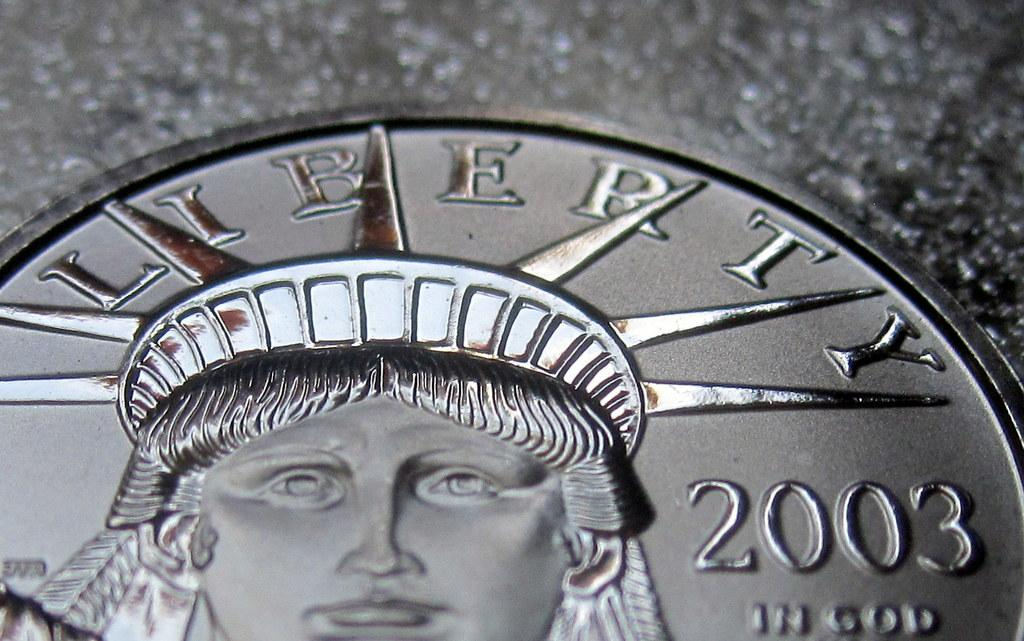<image>
Share a concise interpretation of the image provided. Silver coin that has the year 2003 on the right. 